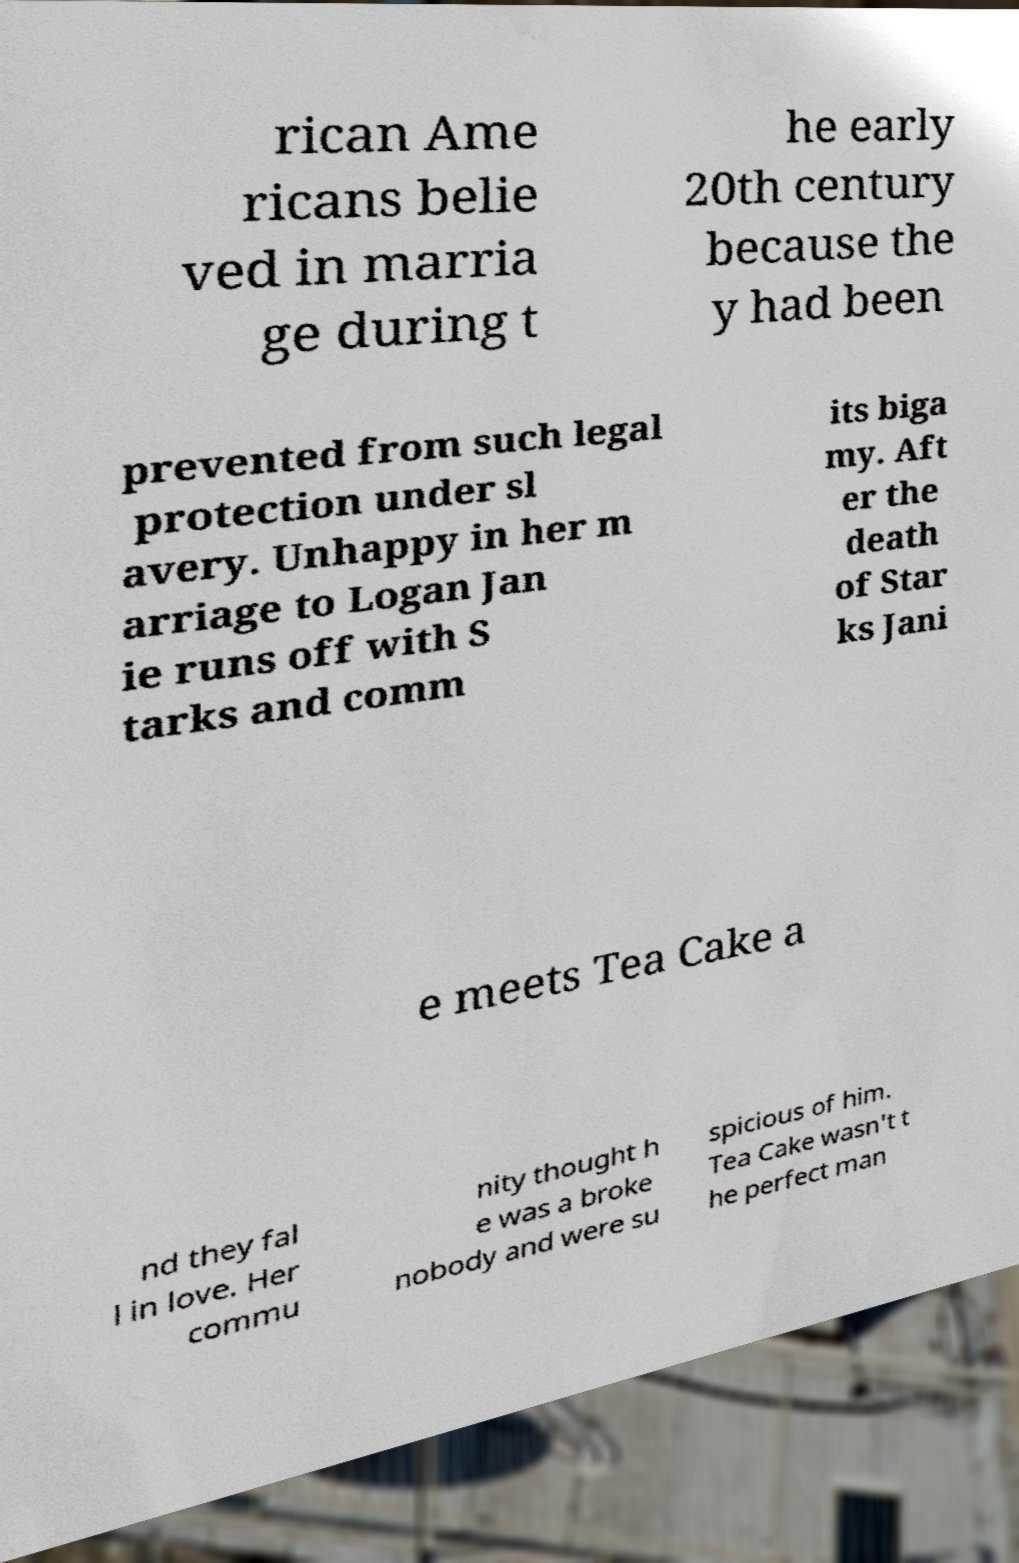For documentation purposes, I need the text within this image transcribed. Could you provide that? rican Ame ricans belie ved in marria ge during t he early 20th century because the y had been prevented from such legal protection under sl avery. Unhappy in her m arriage to Logan Jan ie runs off with S tarks and comm its biga my. Aft er the death of Star ks Jani e meets Tea Cake a nd they fal l in love. Her commu nity thought h e was a broke nobody and were su spicious of him. Tea Cake wasn't t he perfect man 